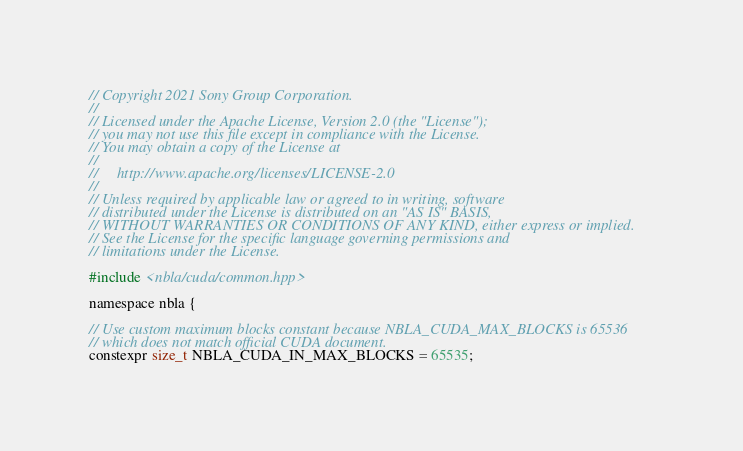Convert code to text. <code><loc_0><loc_0><loc_500><loc_500><_Cuda_>// Copyright 2021 Sony Group Corporation.
//
// Licensed under the Apache License, Version 2.0 (the "License");
// you may not use this file except in compliance with the License.
// You may obtain a copy of the License at
//
//     http://www.apache.org/licenses/LICENSE-2.0
//
// Unless required by applicable law or agreed to in writing, software
// distributed under the License is distributed on an "AS IS" BASIS,
// WITHOUT WARRANTIES OR CONDITIONS OF ANY KIND, either express or implied.
// See the License for the specific language governing permissions and
// limitations under the License.

#include <nbla/cuda/common.hpp>

namespace nbla {

// Use custom maximum blocks constant because NBLA_CUDA_MAX_BLOCKS is 65536
// which does not match official CUDA document.
constexpr size_t NBLA_CUDA_IN_MAX_BLOCKS = 65535;</code> 